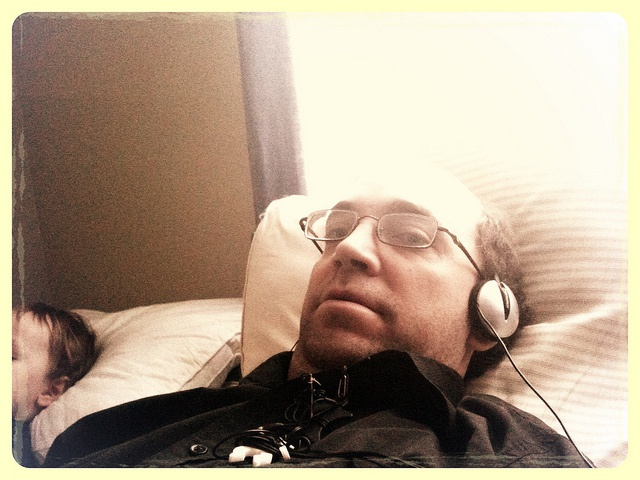Describe the objects in this image and their specific colors. I can see people in lightyellow, black, beige, brown, and maroon tones, bed in lightyellow, ivory, and tan tones, and people in lightyellow, black, tan, brown, and maroon tones in this image. 